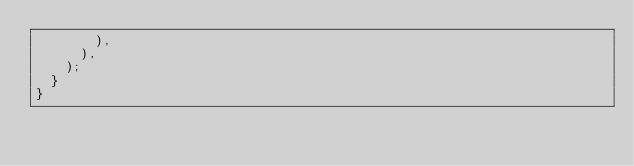Convert code to text. <code><loc_0><loc_0><loc_500><loc_500><_Dart_>        ),
      ),
    );
  }
}
</code> 